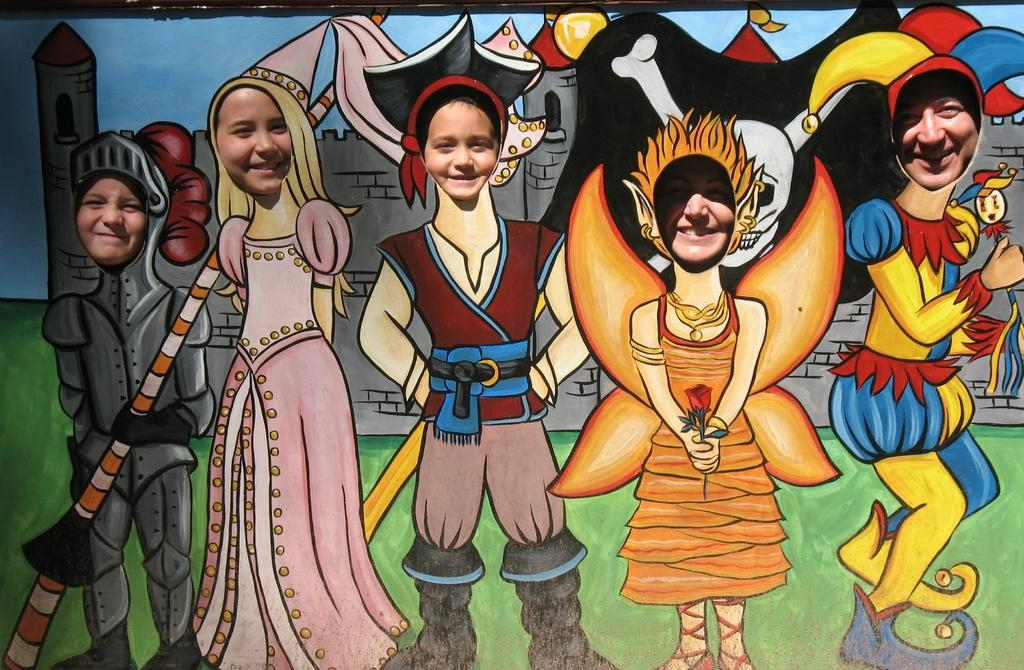What is the main feature of the image? There is a big poster in the image. What is depicted on the poster? The poster contains different animated images with their heads cut. What are the people in the image doing? The people are replacing the heads of the animated images. Can you describe the animated images on the poster? The animated images are not described in detail, but they have their heads cut. How many spiders are crawling on the yard in the image? There are no spiders or yards present in the image; it features a big poster with animated images and people replacing their heads. 